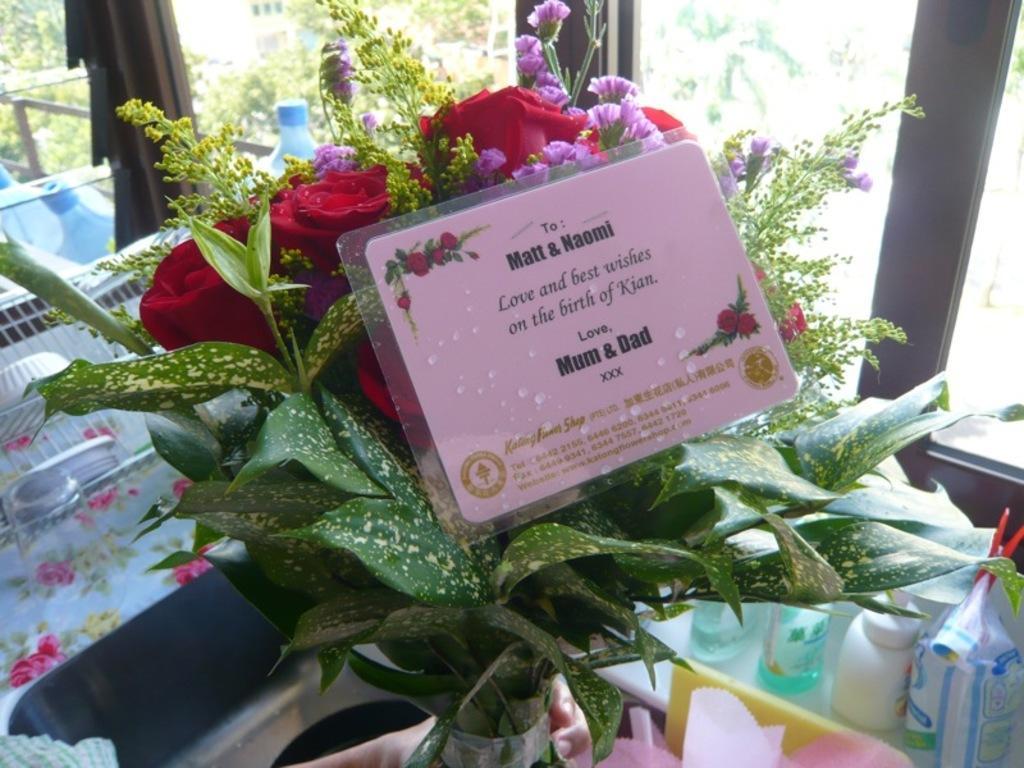Describe this image in one or two sentences. In the center of the image there is a flower vase. At the bottom of the image there are many objects. 